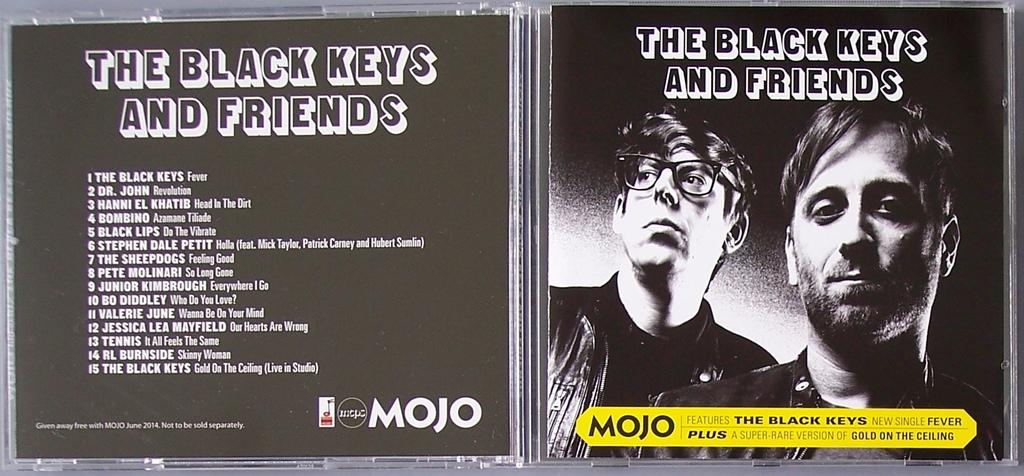What is the color of the object in the image? The object in the image is black. What is depicted on the object? The object has a picture of two persons. Are there any words or letters on the object? Yes, there is text visible on the black color object. Can you tell me how many pickles are floating in the boat in the image? There is no boat or pickles present in the image; it features a black object with a picture of two persons and text. 